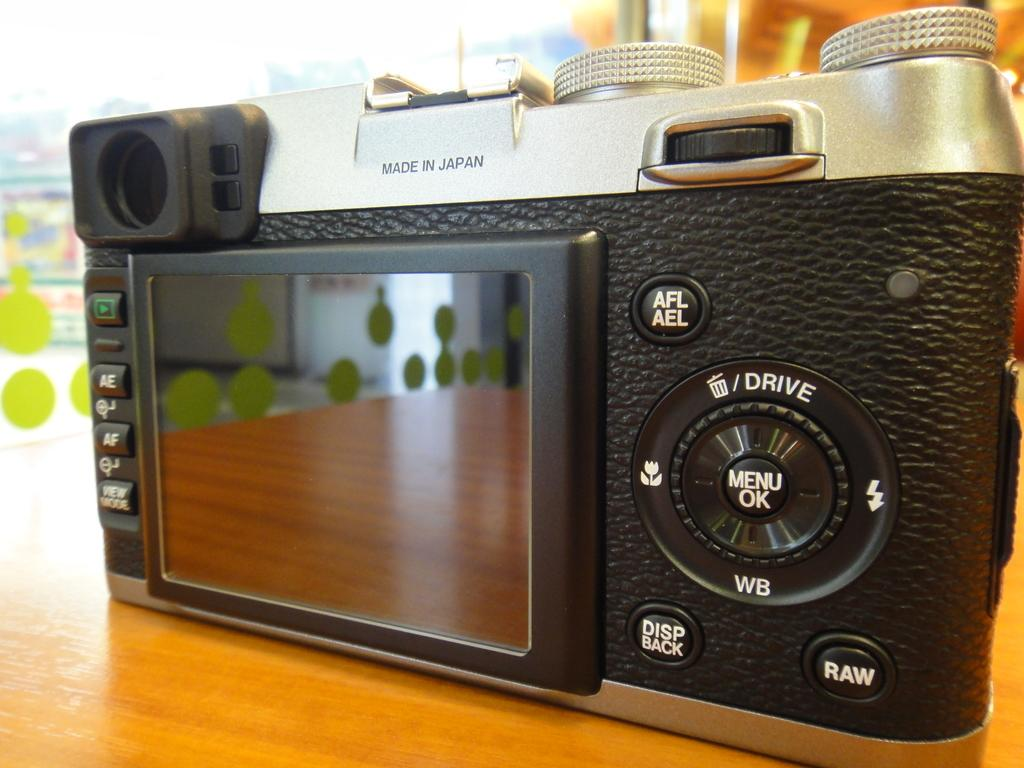Where was the image taken? The image is taken indoors. What can be seen on the table in the image? There is a camera on the table. Can you describe the background of the image? The background of the image is a little blurred. How many fish can be seen in the image? There are no fish present in the image. 